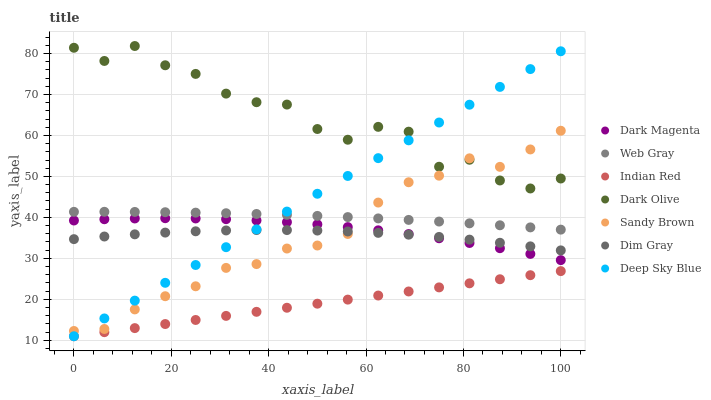Does Indian Red have the minimum area under the curve?
Answer yes or no. Yes. Does Dark Olive have the maximum area under the curve?
Answer yes or no. Yes. Does Dark Magenta have the minimum area under the curve?
Answer yes or no. No. Does Dark Magenta have the maximum area under the curve?
Answer yes or no. No. Is Deep Sky Blue the smoothest?
Answer yes or no. Yes. Is Dark Olive the roughest?
Answer yes or no. Yes. Is Dark Magenta the smoothest?
Answer yes or no. No. Is Dark Magenta the roughest?
Answer yes or no. No. Does Indian Red have the lowest value?
Answer yes or no. Yes. Does Dark Magenta have the lowest value?
Answer yes or no. No. Does Dark Olive have the highest value?
Answer yes or no. Yes. Does Dark Magenta have the highest value?
Answer yes or no. No. Is Dim Gray less than Dark Olive?
Answer yes or no. Yes. Is Dim Gray greater than Indian Red?
Answer yes or no. Yes. Does Dark Olive intersect Sandy Brown?
Answer yes or no. Yes. Is Dark Olive less than Sandy Brown?
Answer yes or no. No. Is Dark Olive greater than Sandy Brown?
Answer yes or no. No. Does Dim Gray intersect Dark Olive?
Answer yes or no. No. 